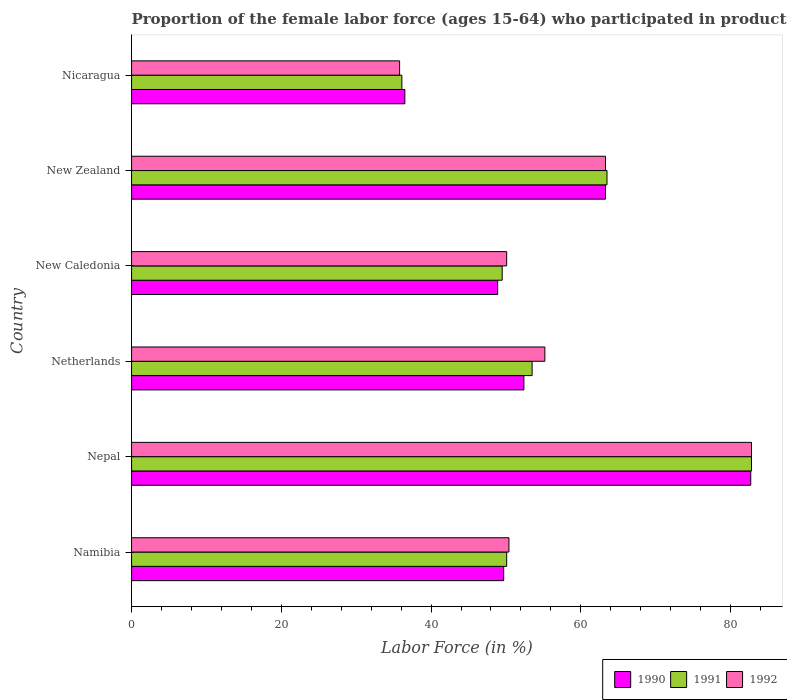How many different coloured bars are there?
Keep it short and to the point. 3. Are the number of bars per tick equal to the number of legend labels?
Your answer should be compact. Yes. How many bars are there on the 5th tick from the top?
Ensure brevity in your answer.  3. What is the label of the 5th group of bars from the top?
Your response must be concise. Nepal. What is the proportion of the female labor force who participated in production in 1991 in New Zealand?
Your answer should be compact. 63.5. Across all countries, what is the maximum proportion of the female labor force who participated in production in 1991?
Offer a very short reply. 82.8. Across all countries, what is the minimum proportion of the female labor force who participated in production in 1992?
Keep it short and to the point. 35.8. In which country was the proportion of the female labor force who participated in production in 1992 maximum?
Your answer should be compact. Nepal. In which country was the proportion of the female labor force who participated in production in 1990 minimum?
Your answer should be compact. Nicaragua. What is the total proportion of the female labor force who participated in production in 1992 in the graph?
Your response must be concise. 337.6. What is the difference between the proportion of the female labor force who participated in production in 1991 in Netherlands and that in New Zealand?
Your answer should be very brief. -10. What is the difference between the proportion of the female labor force who participated in production in 1990 in Nepal and the proportion of the female labor force who participated in production in 1992 in New Caledonia?
Offer a very short reply. 32.6. What is the average proportion of the female labor force who participated in production in 1990 per country?
Keep it short and to the point. 55.58. What is the difference between the proportion of the female labor force who participated in production in 1990 and proportion of the female labor force who participated in production in 1991 in Nicaragua?
Keep it short and to the point. 0.4. In how many countries, is the proportion of the female labor force who participated in production in 1991 greater than 40 %?
Offer a very short reply. 5. What is the ratio of the proportion of the female labor force who participated in production in 1990 in Netherlands to that in Nicaragua?
Your answer should be compact. 1.44. Is the proportion of the female labor force who participated in production in 1990 in New Zealand less than that in Nicaragua?
Your answer should be compact. No. Is the difference between the proportion of the female labor force who participated in production in 1990 in Namibia and Nicaragua greater than the difference between the proportion of the female labor force who participated in production in 1991 in Namibia and Nicaragua?
Provide a short and direct response. No. What is the difference between the highest and the second highest proportion of the female labor force who participated in production in 1990?
Your answer should be very brief. 19.4. What is the difference between the highest and the lowest proportion of the female labor force who participated in production in 1991?
Provide a short and direct response. 46.7. How many bars are there?
Make the answer very short. 18. How many countries are there in the graph?
Offer a very short reply. 6. Does the graph contain grids?
Give a very brief answer. No. Where does the legend appear in the graph?
Offer a very short reply. Bottom right. How are the legend labels stacked?
Keep it short and to the point. Horizontal. What is the title of the graph?
Ensure brevity in your answer.  Proportion of the female labor force (ages 15-64) who participated in production. What is the Labor Force (in %) of 1990 in Namibia?
Ensure brevity in your answer.  49.7. What is the Labor Force (in %) in 1991 in Namibia?
Provide a succinct answer. 50.1. What is the Labor Force (in %) in 1992 in Namibia?
Make the answer very short. 50.4. What is the Labor Force (in %) in 1990 in Nepal?
Provide a short and direct response. 82.7. What is the Labor Force (in %) in 1991 in Nepal?
Provide a succinct answer. 82.8. What is the Labor Force (in %) of 1992 in Nepal?
Your response must be concise. 82.8. What is the Labor Force (in %) in 1990 in Netherlands?
Give a very brief answer. 52.4. What is the Labor Force (in %) of 1991 in Netherlands?
Your answer should be very brief. 53.5. What is the Labor Force (in %) in 1992 in Netherlands?
Offer a very short reply. 55.2. What is the Labor Force (in %) in 1990 in New Caledonia?
Offer a very short reply. 48.9. What is the Labor Force (in %) of 1991 in New Caledonia?
Offer a terse response. 49.5. What is the Labor Force (in %) in 1992 in New Caledonia?
Your answer should be very brief. 50.1. What is the Labor Force (in %) in 1990 in New Zealand?
Your response must be concise. 63.3. What is the Labor Force (in %) in 1991 in New Zealand?
Offer a very short reply. 63.5. What is the Labor Force (in %) of 1992 in New Zealand?
Provide a short and direct response. 63.3. What is the Labor Force (in %) of 1990 in Nicaragua?
Make the answer very short. 36.5. What is the Labor Force (in %) of 1991 in Nicaragua?
Offer a terse response. 36.1. What is the Labor Force (in %) of 1992 in Nicaragua?
Make the answer very short. 35.8. Across all countries, what is the maximum Labor Force (in %) in 1990?
Keep it short and to the point. 82.7. Across all countries, what is the maximum Labor Force (in %) in 1991?
Your answer should be very brief. 82.8. Across all countries, what is the maximum Labor Force (in %) in 1992?
Your answer should be very brief. 82.8. Across all countries, what is the minimum Labor Force (in %) in 1990?
Offer a very short reply. 36.5. Across all countries, what is the minimum Labor Force (in %) in 1991?
Your response must be concise. 36.1. Across all countries, what is the minimum Labor Force (in %) of 1992?
Keep it short and to the point. 35.8. What is the total Labor Force (in %) of 1990 in the graph?
Provide a succinct answer. 333.5. What is the total Labor Force (in %) of 1991 in the graph?
Your response must be concise. 335.5. What is the total Labor Force (in %) of 1992 in the graph?
Provide a succinct answer. 337.6. What is the difference between the Labor Force (in %) of 1990 in Namibia and that in Nepal?
Make the answer very short. -33. What is the difference between the Labor Force (in %) in 1991 in Namibia and that in Nepal?
Ensure brevity in your answer.  -32.7. What is the difference between the Labor Force (in %) in 1992 in Namibia and that in Nepal?
Make the answer very short. -32.4. What is the difference between the Labor Force (in %) in 1990 in Namibia and that in Netherlands?
Provide a short and direct response. -2.7. What is the difference between the Labor Force (in %) of 1992 in Namibia and that in Netherlands?
Your answer should be compact. -4.8. What is the difference between the Labor Force (in %) of 1991 in Namibia and that in New Caledonia?
Provide a succinct answer. 0.6. What is the difference between the Labor Force (in %) of 1990 in Namibia and that in New Zealand?
Keep it short and to the point. -13.6. What is the difference between the Labor Force (in %) of 1992 in Namibia and that in New Zealand?
Your response must be concise. -12.9. What is the difference between the Labor Force (in %) in 1991 in Namibia and that in Nicaragua?
Your answer should be very brief. 14. What is the difference between the Labor Force (in %) in 1992 in Namibia and that in Nicaragua?
Your response must be concise. 14.6. What is the difference between the Labor Force (in %) of 1990 in Nepal and that in Netherlands?
Your answer should be very brief. 30.3. What is the difference between the Labor Force (in %) of 1991 in Nepal and that in Netherlands?
Offer a terse response. 29.3. What is the difference between the Labor Force (in %) of 1992 in Nepal and that in Netherlands?
Offer a terse response. 27.6. What is the difference between the Labor Force (in %) in 1990 in Nepal and that in New Caledonia?
Make the answer very short. 33.8. What is the difference between the Labor Force (in %) of 1991 in Nepal and that in New Caledonia?
Your answer should be very brief. 33.3. What is the difference between the Labor Force (in %) of 1992 in Nepal and that in New Caledonia?
Offer a very short reply. 32.7. What is the difference between the Labor Force (in %) in 1991 in Nepal and that in New Zealand?
Your answer should be compact. 19.3. What is the difference between the Labor Force (in %) of 1992 in Nepal and that in New Zealand?
Ensure brevity in your answer.  19.5. What is the difference between the Labor Force (in %) of 1990 in Nepal and that in Nicaragua?
Keep it short and to the point. 46.2. What is the difference between the Labor Force (in %) of 1991 in Nepal and that in Nicaragua?
Ensure brevity in your answer.  46.7. What is the difference between the Labor Force (in %) of 1992 in Nepal and that in Nicaragua?
Offer a very short reply. 47. What is the difference between the Labor Force (in %) in 1991 in Netherlands and that in New Zealand?
Give a very brief answer. -10. What is the difference between the Labor Force (in %) of 1992 in Netherlands and that in New Zealand?
Your response must be concise. -8.1. What is the difference between the Labor Force (in %) in 1990 in Netherlands and that in Nicaragua?
Your response must be concise. 15.9. What is the difference between the Labor Force (in %) in 1991 in Netherlands and that in Nicaragua?
Ensure brevity in your answer.  17.4. What is the difference between the Labor Force (in %) of 1992 in Netherlands and that in Nicaragua?
Give a very brief answer. 19.4. What is the difference between the Labor Force (in %) of 1990 in New Caledonia and that in New Zealand?
Provide a succinct answer. -14.4. What is the difference between the Labor Force (in %) of 1992 in New Caledonia and that in New Zealand?
Your answer should be compact. -13.2. What is the difference between the Labor Force (in %) in 1990 in New Caledonia and that in Nicaragua?
Keep it short and to the point. 12.4. What is the difference between the Labor Force (in %) of 1992 in New Caledonia and that in Nicaragua?
Provide a short and direct response. 14.3. What is the difference between the Labor Force (in %) of 1990 in New Zealand and that in Nicaragua?
Make the answer very short. 26.8. What is the difference between the Labor Force (in %) in 1991 in New Zealand and that in Nicaragua?
Your answer should be compact. 27.4. What is the difference between the Labor Force (in %) in 1992 in New Zealand and that in Nicaragua?
Your answer should be very brief. 27.5. What is the difference between the Labor Force (in %) in 1990 in Namibia and the Labor Force (in %) in 1991 in Nepal?
Make the answer very short. -33.1. What is the difference between the Labor Force (in %) in 1990 in Namibia and the Labor Force (in %) in 1992 in Nepal?
Offer a terse response. -33.1. What is the difference between the Labor Force (in %) of 1991 in Namibia and the Labor Force (in %) of 1992 in Nepal?
Offer a very short reply. -32.7. What is the difference between the Labor Force (in %) in 1990 in Namibia and the Labor Force (in %) in 1991 in Netherlands?
Your response must be concise. -3.8. What is the difference between the Labor Force (in %) in 1990 in Namibia and the Labor Force (in %) in 1992 in Netherlands?
Ensure brevity in your answer.  -5.5. What is the difference between the Labor Force (in %) of 1990 in Namibia and the Labor Force (in %) of 1992 in New Caledonia?
Ensure brevity in your answer.  -0.4. What is the difference between the Labor Force (in %) of 1991 in Namibia and the Labor Force (in %) of 1992 in New Caledonia?
Offer a very short reply. 0. What is the difference between the Labor Force (in %) in 1991 in Namibia and the Labor Force (in %) in 1992 in New Zealand?
Your response must be concise. -13.2. What is the difference between the Labor Force (in %) in 1990 in Namibia and the Labor Force (in %) in 1992 in Nicaragua?
Provide a short and direct response. 13.9. What is the difference between the Labor Force (in %) in 1991 in Namibia and the Labor Force (in %) in 1992 in Nicaragua?
Your answer should be very brief. 14.3. What is the difference between the Labor Force (in %) of 1990 in Nepal and the Labor Force (in %) of 1991 in Netherlands?
Keep it short and to the point. 29.2. What is the difference between the Labor Force (in %) in 1991 in Nepal and the Labor Force (in %) in 1992 in Netherlands?
Your response must be concise. 27.6. What is the difference between the Labor Force (in %) in 1990 in Nepal and the Labor Force (in %) in 1991 in New Caledonia?
Provide a short and direct response. 33.2. What is the difference between the Labor Force (in %) of 1990 in Nepal and the Labor Force (in %) of 1992 in New Caledonia?
Provide a short and direct response. 32.6. What is the difference between the Labor Force (in %) in 1991 in Nepal and the Labor Force (in %) in 1992 in New Caledonia?
Your answer should be very brief. 32.7. What is the difference between the Labor Force (in %) of 1990 in Nepal and the Labor Force (in %) of 1991 in New Zealand?
Your answer should be compact. 19.2. What is the difference between the Labor Force (in %) in 1990 in Nepal and the Labor Force (in %) in 1991 in Nicaragua?
Ensure brevity in your answer.  46.6. What is the difference between the Labor Force (in %) of 1990 in Nepal and the Labor Force (in %) of 1992 in Nicaragua?
Offer a very short reply. 46.9. What is the difference between the Labor Force (in %) in 1990 in Netherlands and the Labor Force (in %) in 1991 in New Caledonia?
Ensure brevity in your answer.  2.9. What is the difference between the Labor Force (in %) in 1990 in Netherlands and the Labor Force (in %) in 1992 in New Caledonia?
Your answer should be compact. 2.3. What is the difference between the Labor Force (in %) of 1991 in Netherlands and the Labor Force (in %) of 1992 in New Caledonia?
Your response must be concise. 3.4. What is the difference between the Labor Force (in %) of 1990 in Netherlands and the Labor Force (in %) of 1991 in New Zealand?
Offer a very short reply. -11.1. What is the difference between the Labor Force (in %) of 1991 in Netherlands and the Labor Force (in %) of 1992 in New Zealand?
Provide a succinct answer. -9.8. What is the difference between the Labor Force (in %) of 1990 in Netherlands and the Labor Force (in %) of 1991 in Nicaragua?
Provide a short and direct response. 16.3. What is the difference between the Labor Force (in %) of 1991 in Netherlands and the Labor Force (in %) of 1992 in Nicaragua?
Make the answer very short. 17.7. What is the difference between the Labor Force (in %) in 1990 in New Caledonia and the Labor Force (in %) in 1991 in New Zealand?
Ensure brevity in your answer.  -14.6. What is the difference between the Labor Force (in %) of 1990 in New Caledonia and the Labor Force (in %) of 1992 in New Zealand?
Your answer should be compact. -14.4. What is the difference between the Labor Force (in %) in 1991 in New Caledonia and the Labor Force (in %) in 1992 in Nicaragua?
Keep it short and to the point. 13.7. What is the difference between the Labor Force (in %) in 1990 in New Zealand and the Labor Force (in %) in 1991 in Nicaragua?
Give a very brief answer. 27.2. What is the difference between the Labor Force (in %) of 1991 in New Zealand and the Labor Force (in %) of 1992 in Nicaragua?
Offer a very short reply. 27.7. What is the average Labor Force (in %) of 1990 per country?
Offer a very short reply. 55.58. What is the average Labor Force (in %) of 1991 per country?
Your response must be concise. 55.92. What is the average Labor Force (in %) in 1992 per country?
Offer a terse response. 56.27. What is the difference between the Labor Force (in %) in 1990 and Labor Force (in %) in 1991 in Namibia?
Your response must be concise. -0.4. What is the difference between the Labor Force (in %) in 1990 and Labor Force (in %) in 1992 in Namibia?
Ensure brevity in your answer.  -0.7. What is the difference between the Labor Force (in %) in 1990 and Labor Force (in %) in 1991 in Nepal?
Provide a short and direct response. -0.1. What is the difference between the Labor Force (in %) of 1991 and Labor Force (in %) of 1992 in Nepal?
Your answer should be compact. 0. What is the difference between the Labor Force (in %) in 1990 and Labor Force (in %) in 1991 in Netherlands?
Provide a succinct answer. -1.1. What is the difference between the Labor Force (in %) in 1991 and Labor Force (in %) in 1992 in Netherlands?
Offer a very short reply. -1.7. What is the difference between the Labor Force (in %) of 1990 and Labor Force (in %) of 1991 in New Caledonia?
Your response must be concise. -0.6. What is the difference between the Labor Force (in %) in 1990 and Labor Force (in %) in 1992 in New Caledonia?
Make the answer very short. -1.2. What is the difference between the Labor Force (in %) in 1990 and Labor Force (in %) in 1991 in New Zealand?
Ensure brevity in your answer.  -0.2. What is the difference between the Labor Force (in %) in 1991 and Labor Force (in %) in 1992 in New Zealand?
Keep it short and to the point. 0.2. What is the difference between the Labor Force (in %) of 1990 and Labor Force (in %) of 1991 in Nicaragua?
Ensure brevity in your answer.  0.4. What is the difference between the Labor Force (in %) of 1991 and Labor Force (in %) of 1992 in Nicaragua?
Make the answer very short. 0.3. What is the ratio of the Labor Force (in %) of 1990 in Namibia to that in Nepal?
Your response must be concise. 0.6. What is the ratio of the Labor Force (in %) in 1991 in Namibia to that in Nepal?
Offer a very short reply. 0.61. What is the ratio of the Labor Force (in %) in 1992 in Namibia to that in Nepal?
Offer a terse response. 0.61. What is the ratio of the Labor Force (in %) of 1990 in Namibia to that in Netherlands?
Your response must be concise. 0.95. What is the ratio of the Labor Force (in %) of 1991 in Namibia to that in Netherlands?
Your answer should be compact. 0.94. What is the ratio of the Labor Force (in %) in 1992 in Namibia to that in Netherlands?
Your answer should be compact. 0.91. What is the ratio of the Labor Force (in %) in 1990 in Namibia to that in New Caledonia?
Make the answer very short. 1.02. What is the ratio of the Labor Force (in %) in 1991 in Namibia to that in New Caledonia?
Offer a terse response. 1.01. What is the ratio of the Labor Force (in %) of 1990 in Namibia to that in New Zealand?
Give a very brief answer. 0.79. What is the ratio of the Labor Force (in %) in 1991 in Namibia to that in New Zealand?
Keep it short and to the point. 0.79. What is the ratio of the Labor Force (in %) in 1992 in Namibia to that in New Zealand?
Make the answer very short. 0.8. What is the ratio of the Labor Force (in %) of 1990 in Namibia to that in Nicaragua?
Your response must be concise. 1.36. What is the ratio of the Labor Force (in %) in 1991 in Namibia to that in Nicaragua?
Your answer should be very brief. 1.39. What is the ratio of the Labor Force (in %) of 1992 in Namibia to that in Nicaragua?
Your response must be concise. 1.41. What is the ratio of the Labor Force (in %) in 1990 in Nepal to that in Netherlands?
Provide a short and direct response. 1.58. What is the ratio of the Labor Force (in %) of 1991 in Nepal to that in Netherlands?
Your answer should be very brief. 1.55. What is the ratio of the Labor Force (in %) in 1990 in Nepal to that in New Caledonia?
Offer a very short reply. 1.69. What is the ratio of the Labor Force (in %) of 1991 in Nepal to that in New Caledonia?
Offer a very short reply. 1.67. What is the ratio of the Labor Force (in %) in 1992 in Nepal to that in New Caledonia?
Make the answer very short. 1.65. What is the ratio of the Labor Force (in %) of 1990 in Nepal to that in New Zealand?
Provide a succinct answer. 1.31. What is the ratio of the Labor Force (in %) in 1991 in Nepal to that in New Zealand?
Offer a terse response. 1.3. What is the ratio of the Labor Force (in %) in 1992 in Nepal to that in New Zealand?
Provide a short and direct response. 1.31. What is the ratio of the Labor Force (in %) of 1990 in Nepal to that in Nicaragua?
Provide a succinct answer. 2.27. What is the ratio of the Labor Force (in %) in 1991 in Nepal to that in Nicaragua?
Give a very brief answer. 2.29. What is the ratio of the Labor Force (in %) in 1992 in Nepal to that in Nicaragua?
Make the answer very short. 2.31. What is the ratio of the Labor Force (in %) in 1990 in Netherlands to that in New Caledonia?
Provide a short and direct response. 1.07. What is the ratio of the Labor Force (in %) in 1991 in Netherlands to that in New Caledonia?
Your answer should be very brief. 1.08. What is the ratio of the Labor Force (in %) in 1992 in Netherlands to that in New Caledonia?
Provide a short and direct response. 1.1. What is the ratio of the Labor Force (in %) in 1990 in Netherlands to that in New Zealand?
Your answer should be very brief. 0.83. What is the ratio of the Labor Force (in %) of 1991 in Netherlands to that in New Zealand?
Keep it short and to the point. 0.84. What is the ratio of the Labor Force (in %) in 1992 in Netherlands to that in New Zealand?
Offer a very short reply. 0.87. What is the ratio of the Labor Force (in %) in 1990 in Netherlands to that in Nicaragua?
Keep it short and to the point. 1.44. What is the ratio of the Labor Force (in %) in 1991 in Netherlands to that in Nicaragua?
Ensure brevity in your answer.  1.48. What is the ratio of the Labor Force (in %) of 1992 in Netherlands to that in Nicaragua?
Provide a succinct answer. 1.54. What is the ratio of the Labor Force (in %) of 1990 in New Caledonia to that in New Zealand?
Keep it short and to the point. 0.77. What is the ratio of the Labor Force (in %) in 1991 in New Caledonia to that in New Zealand?
Your answer should be compact. 0.78. What is the ratio of the Labor Force (in %) in 1992 in New Caledonia to that in New Zealand?
Give a very brief answer. 0.79. What is the ratio of the Labor Force (in %) in 1990 in New Caledonia to that in Nicaragua?
Your response must be concise. 1.34. What is the ratio of the Labor Force (in %) of 1991 in New Caledonia to that in Nicaragua?
Provide a short and direct response. 1.37. What is the ratio of the Labor Force (in %) in 1992 in New Caledonia to that in Nicaragua?
Your answer should be compact. 1.4. What is the ratio of the Labor Force (in %) of 1990 in New Zealand to that in Nicaragua?
Keep it short and to the point. 1.73. What is the ratio of the Labor Force (in %) in 1991 in New Zealand to that in Nicaragua?
Offer a very short reply. 1.76. What is the ratio of the Labor Force (in %) in 1992 in New Zealand to that in Nicaragua?
Give a very brief answer. 1.77. What is the difference between the highest and the second highest Labor Force (in %) in 1991?
Provide a succinct answer. 19.3. What is the difference between the highest and the second highest Labor Force (in %) of 1992?
Your response must be concise. 19.5. What is the difference between the highest and the lowest Labor Force (in %) of 1990?
Provide a short and direct response. 46.2. What is the difference between the highest and the lowest Labor Force (in %) of 1991?
Offer a very short reply. 46.7. 